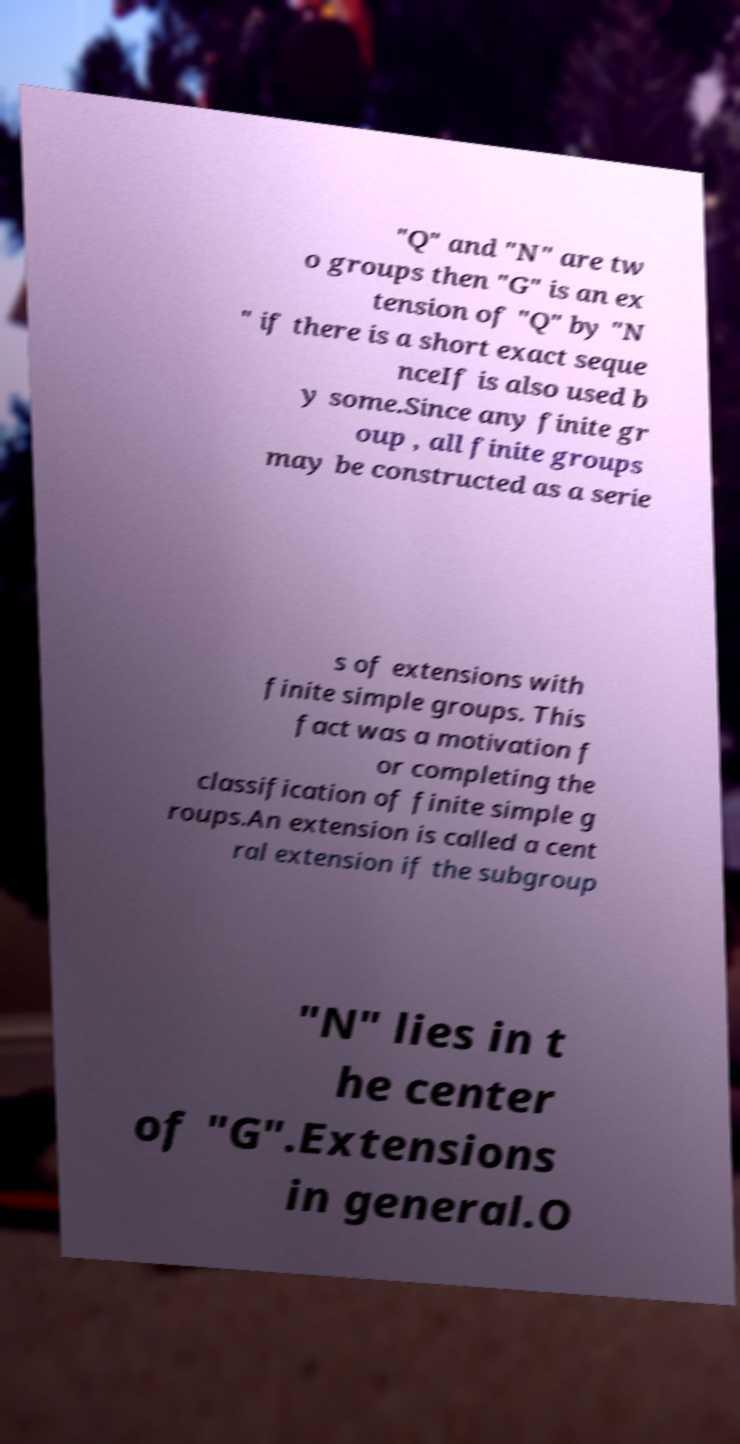Could you extract and type out the text from this image? "Q" and "N" are tw o groups then "G" is an ex tension of "Q" by "N " if there is a short exact seque nceIf is also used b y some.Since any finite gr oup , all finite groups may be constructed as a serie s of extensions with finite simple groups. This fact was a motivation f or completing the classification of finite simple g roups.An extension is called a cent ral extension if the subgroup "N" lies in t he center of "G".Extensions in general.O 